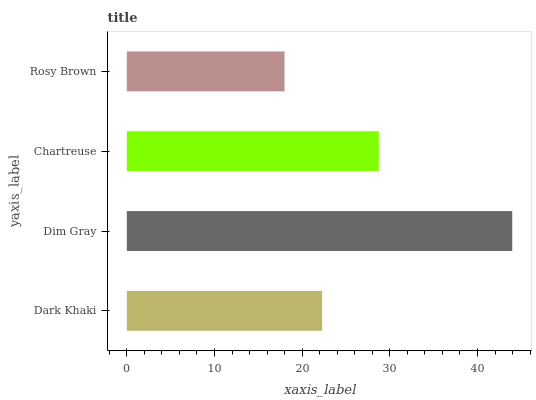Is Rosy Brown the minimum?
Answer yes or no. Yes. Is Dim Gray the maximum?
Answer yes or no. Yes. Is Chartreuse the minimum?
Answer yes or no. No. Is Chartreuse the maximum?
Answer yes or no. No. Is Dim Gray greater than Chartreuse?
Answer yes or no. Yes. Is Chartreuse less than Dim Gray?
Answer yes or no. Yes. Is Chartreuse greater than Dim Gray?
Answer yes or no. No. Is Dim Gray less than Chartreuse?
Answer yes or no. No. Is Chartreuse the high median?
Answer yes or no. Yes. Is Dark Khaki the low median?
Answer yes or no. Yes. Is Dim Gray the high median?
Answer yes or no. No. Is Chartreuse the low median?
Answer yes or no. No. 